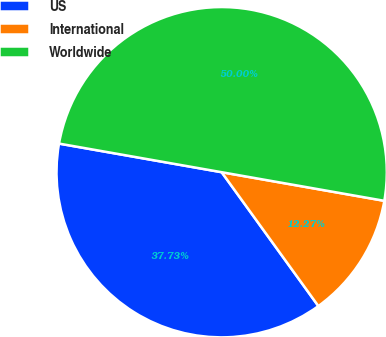<chart> <loc_0><loc_0><loc_500><loc_500><pie_chart><fcel>US<fcel>International<fcel>Worldwide<nl><fcel>37.73%<fcel>12.27%<fcel>50.0%<nl></chart> 